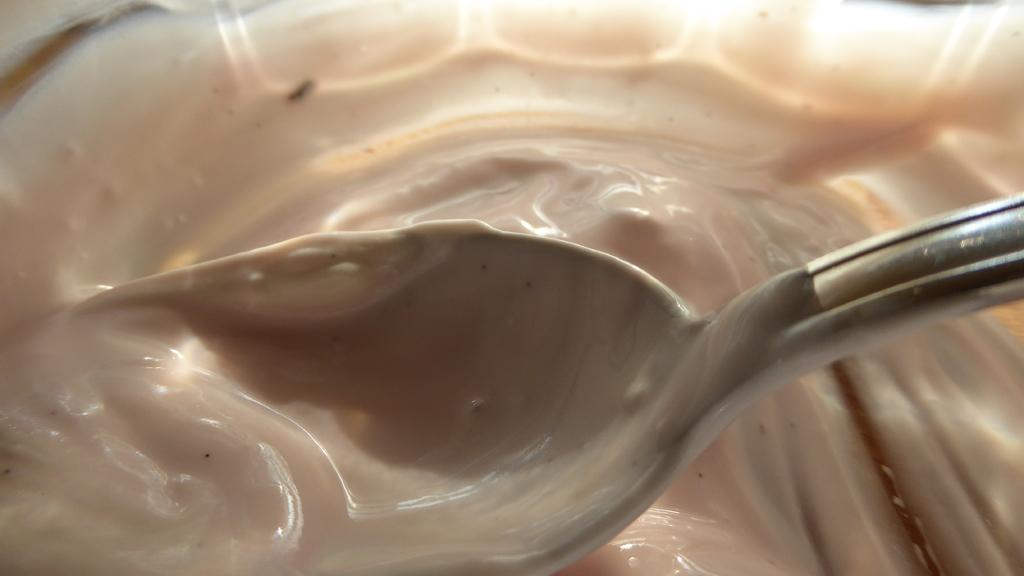What type of utensil is visible in the image? There is a steel spoon in the image. How is the spoon positioned in relation to the cream? The spoon is partially in the cream. What color is the background of the image? The background of the image is cream in color. Who is the authority figure in the image? There is no authority figure present in the image; it only features a steel spoon and cream. Can you tell me how many friends are visible in the image? There are no friends visible in the image; it only features a steel spoon and cream. 